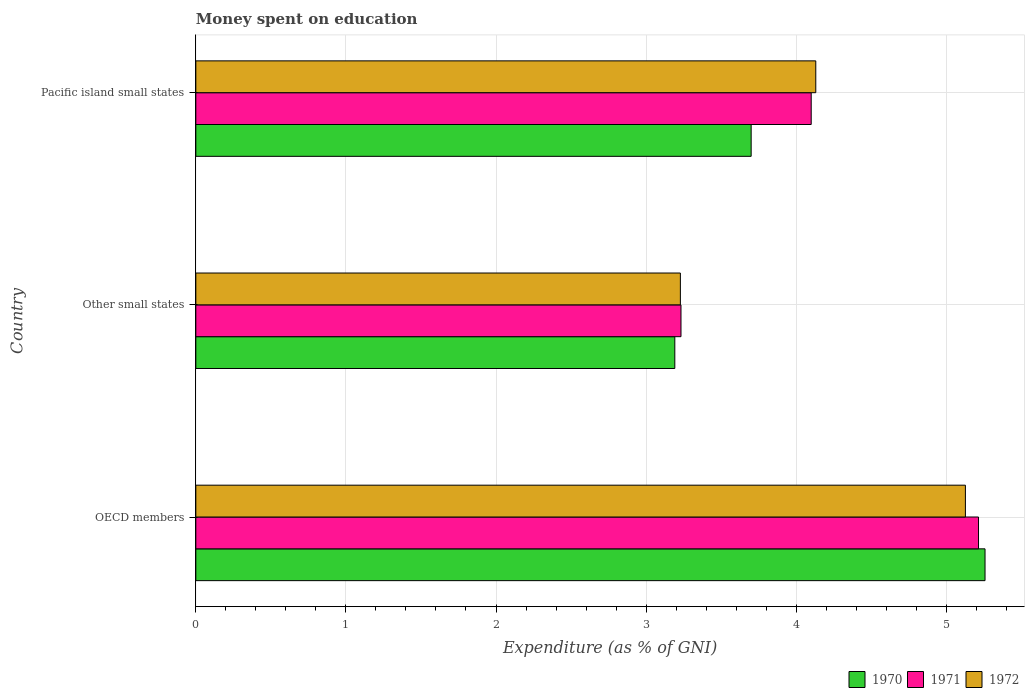How many different coloured bars are there?
Your answer should be very brief. 3. How many groups of bars are there?
Your response must be concise. 3. Are the number of bars on each tick of the Y-axis equal?
Provide a short and direct response. Yes. How many bars are there on the 3rd tick from the top?
Ensure brevity in your answer.  3. How many bars are there on the 1st tick from the bottom?
Your response must be concise. 3. What is the label of the 2nd group of bars from the top?
Ensure brevity in your answer.  Other small states. In how many cases, is the number of bars for a given country not equal to the number of legend labels?
Provide a short and direct response. 0. What is the amount of money spent on education in 1971 in OECD members?
Provide a succinct answer. 5.21. Across all countries, what is the maximum amount of money spent on education in 1972?
Keep it short and to the point. 5.13. Across all countries, what is the minimum amount of money spent on education in 1970?
Give a very brief answer. 3.19. In which country was the amount of money spent on education in 1971 minimum?
Your answer should be compact. Other small states. What is the total amount of money spent on education in 1971 in the graph?
Provide a short and direct response. 12.55. What is the difference between the amount of money spent on education in 1971 in OECD members and that in Pacific island small states?
Give a very brief answer. 1.11. What is the difference between the amount of money spent on education in 1971 in Other small states and the amount of money spent on education in 1970 in OECD members?
Keep it short and to the point. -2.03. What is the average amount of money spent on education in 1971 per country?
Give a very brief answer. 4.18. What is the difference between the amount of money spent on education in 1971 and amount of money spent on education in 1972 in Other small states?
Offer a terse response. 0. In how many countries, is the amount of money spent on education in 1971 greater than 0.2 %?
Your answer should be very brief. 3. What is the ratio of the amount of money spent on education in 1970 in Other small states to that in Pacific island small states?
Your answer should be compact. 0.86. Is the amount of money spent on education in 1970 in OECD members less than that in Other small states?
Offer a very short reply. No. What is the difference between the highest and the second highest amount of money spent on education in 1970?
Ensure brevity in your answer.  1.56. What is the difference between the highest and the lowest amount of money spent on education in 1970?
Your answer should be very brief. 2.07. In how many countries, is the amount of money spent on education in 1970 greater than the average amount of money spent on education in 1970 taken over all countries?
Offer a terse response. 1. Is the sum of the amount of money spent on education in 1972 in OECD members and Other small states greater than the maximum amount of money spent on education in 1970 across all countries?
Your answer should be compact. Yes. What does the 3rd bar from the top in Pacific island small states represents?
Your answer should be compact. 1970. Is it the case that in every country, the sum of the amount of money spent on education in 1972 and amount of money spent on education in 1970 is greater than the amount of money spent on education in 1971?
Give a very brief answer. Yes. Are all the bars in the graph horizontal?
Your answer should be compact. Yes. How many countries are there in the graph?
Your answer should be very brief. 3. What is the difference between two consecutive major ticks on the X-axis?
Ensure brevity in your answer.  1. Where does the legend appear in the graph?
Make the answer very short. Bottom right. How many legend labels are there?
Ensure brevity in your answer.  3. How are the legend labels stacked?
Give a very brief answer. Horizontal. What is the title of the graph?
Ensure brevity in your answer.  Money spent on education. Does "2013" appear as one of the legend labels in the graph?
Your response must be concise. No. What is the label or title of the X-axis?
Keep it short and to the point. Expenditure (as % of GNI). What is the Expenditure (as % of GNI) in 1970 in OECD members?
Provide a succinct answer. 5.26. What is the Expenditure (as % of GNI) in 1971 in OECD members?
Offer a very short reply. 5.21. What is the Expenditure (as % of GNI) in 1972 in OECD members?
Your answer should be compact. 5.13. What is the Expenditure (as % of GNI) of 1970 in Other small states?
Your answer should be compact. 3.19. What is the Expenditure (as % of GNI) of 1971 in Other small states?
Your answer should be very brief. 3.23. What is the Expenditure (as % of GNI) in 1972 in Other small states?
Offer a terse response. 3.23. What is the Expenditure (as % of GNI) in 1972 in Pacific island small states?
Make the answer very short. 4.13. Across all countries, what is the maximum Expenditure (as % of GNI) in 1970?
Offer a terse response. 5.26. Across all countries, what is the maximum Expenditure (as % of GNI) of 1971?
Give a very brief answer. 5.21. Across all countries, what is the maximum Expenditure (as % of GNI) of 1972?
Ensure brevity in your answer.  5.13. Across all countries, what is the minimum Expenditure (as % of GNI) in 1970?
Make the answer very short. 3.19. Across all countries, what is the minimum Expenditure (as % of GNI) in 1971?
Keep it short and to the point. 3.23. Across all countries, what is the minimum Expenditure (as % of GNI) in 1972?
Make the answer very short. 3.23. What is the total Expenditure (as % of GNI) in 1970 in the graph?
Ensure brevity in your answer.  12.15. What is the total Expenditure (as % of GNI) of 1971 in the graph?
Offer a terse response. 12.55. What is the total Expenditure (as % of GNI) of 1972 in the graph?
Offer a terse response. 12.49. What is the difference between the Expenditure (as % of GNI) of 1970 in OECD members and that in Other small states?
Give a very brief answer. 2.07. What is the difference between the Expenditure (as % of GNI) in 1971 in OECD members and that in Other small states?
Provide a succinct answer. 1.98. What is the difference between the Expenditure (as % of GNI) of 1972 in OECD members and that in Other small states?
Make the answer very short. 1.9. What is the difference between the Expenditure (as % of GNI) of 1970 in OECD members and that in Pacific island small states?
Offer a terse response. 1.56. What is the difference between the Expenditure (as % of GNI) of 1971 in OECD members and that in Pacific island small states?
Your response must be concise. 1.11. What is the difference between the Expenditure (as % of GNI) of 1970 in Other small states and that in Pacific island small states?
Offer a terse response. -0.51. What is the difference between the Expenditure (as % of GNI) in 1971 in Other small states and that in Pacific island small states?
Your response must be concise. -0.87. What is the difference between the Expenditure (as % of GNI) of 1972 in Other small states and that in Pacific island small states?
Offer a very short reply. -0.9. What is the difference between the Expenditure (as % of GNI) in 1970 in OECD members and the Expenditure (as % of GNI) in 1971 in Other small states?
Provide a short and direct response. 2.03. What is the difference between the Expenditure (as % of GNI) in 1970 in OECD members and the Expenditure (as % of GNI) in 1972 in Other small states?
Keep it short and to the point. 2.03. What is the difference between the Expenditure (as % of GNI) of 1971 in OECD members and the Expenditure (as % of GNI) of 1972 in Other small states?
Provide a short and direct response. 1.99. What is the difference between the Expenditure (as % of GNI) in 1970 in OECD members and the Expenditure (as % of GNI) in 1971 in Pacific island small states?
Ensure brevity in your answer.  1.16. What is the difference between the Expenditure (as % of GNI) in 1970 in OECD members and the Expenditure (as % of GNI) in 1972 in Pacific island small states?
Your answer should be compact. 1.13. What is the difference between the Expenditure (as % of GNI) in 1971 in OECD members and the Expenditure (as % of GNI) in 1972 in Pacific island small states?
Ensure brevity in your answer.  1.08. What is the difference between the Expenditure (as % of GNI) in 1970 in Other small states and the Expenditure (as % of GNI) in 1971 in Pacific island small states?
Provide a succinct answer. -0.91. What is the difference between the Expenditure (as % of GNI) of 1970 in Other small states and the Expenditure (as % of GNI) of 1972 in Pacific island small states?
Offer a terse response. -0.94. What is the difference between the Expenditure (as % of GNI) in 1971 in Other small states and the Expenditure (as % of GNI) in 1972 in Pacific island small states?
Give a very brief answer. -0.9. What is the average Expenditure (as % of GNI) of 1970 per country?
Your response must be concise. 4.05. What is the average Expenditure (as % of GNI) in 1971 per country?
Provide a succinct answer. 4.18. What is the average Expenditure (as % of GNI) of 1972 per country?
Give a very brief answer. 4.16. What is the difference between the Expenditure (as % of GNI) of 1970 and Expenditure (as % of GNI) of 1971 in OECD members?
Keep it short and to the point. 0.04. What is the difference between the Expenditure (as % of GNI) of 1970 and Expenditure (as % of GNI) of 1972 in OECD members?
Make the answer very short. 0.13. What is the difference between the Expenditure (as % of GNI) of 1971 and Expenditure (as % of GNI) of 1972 in OECD members?
Your response must be concise. 0.09. What is the difference between the Expenditure (as % of GNI) in 1970 and Expenditure (as % of GNI) in 1971 in Other small states?
Provide a short and direct response. -0.04. What is the difference between the Expenditure (as % of GNI) in 1970 and Expenditure (as % of GNI) in 1972 in Other small states?
Your answer should be very brief. -0.04. What is the difference between the Expenditure (as % of GNI) of 1971 and Expenditure (as % of GNI) of 1972 in Other small states?
Keep it short and to the point. 0. What is the difference between the Expenditure (as % of GNI) in 1970 and Expenditure (as % of GNI) in 1972 in Pacific island small states?
Keep it short and to the point. -0.43. What is the difference between the Expenditure (as % of GNI) of 1971 and Expenditure (as % of GNI) of 1972 in Pacific island small states?
Your answer should be compact. -0.03. What is the ratio of the Expenditure (as % of GNI) in 1970 in OECD members to that in Other small states?
Provide a short and direct response. 1.65. What is the ratio of the Expenditure (as % of GNI) of 1971 in OECD members to that in Other small states?
Provide a succinct answer. 1.61. What is the ratio of the Expenditure (as % of GNI) in 1972 in OECD members to that in Other small states?
Keep it short and to the point. 1.59. What is the ratio of the Expenditure (as % of GNI) of 1970 in OECD members to that in Pacific island small states?
Provide a short and direct response. 1.42. What is the ratio of the Expenditure (as % of GNI) of 1971 in OECD members to that in Pacific island small states?
Your answer should be compact. 1.27. What is the ratio of the Expenditure (as % of GNI) in 1972 in OECD members to that in Pacific island small states?
Your answer should be very brief. 1.24. What is the ratio of the Expenditure (as % of GNI) in 1970 in Other small states to that in Pacific island small states?
Keep it short and to the point. 0.86. What is the ratio of the Expenditure (as % of GNI) of 1971 in Other small states to that in Pacific island small states?
Provide a short and direct response. 0.79. What is the ratio of the Expenditure (as % of GNI) of 1972 in Other small states to that in Pacific island small states?
Provide a succinct answer. 0.78. What is the difference between the highest and the second highest Expenditure (as % of GNI) of 1970?
Your answer should be very brief. 1.56. What is the difference between the highest and the second highest Expenditure (as % of GNI) of 1971?
Your answer should be very brief. 1.11. What is the difference between the highest and the lowest Expenditure (as % of GNI) in 1970?
Give a very brief answer. 2.07. What is the difference between the highest and the lowest Expenditure (as % of GNI) of 1971?
Your response must be concise. 1.98. What is the difference between the highest and the lowest Expenditure (as % of GNI) in 1972?
Your answer should be compact. 1.9. 